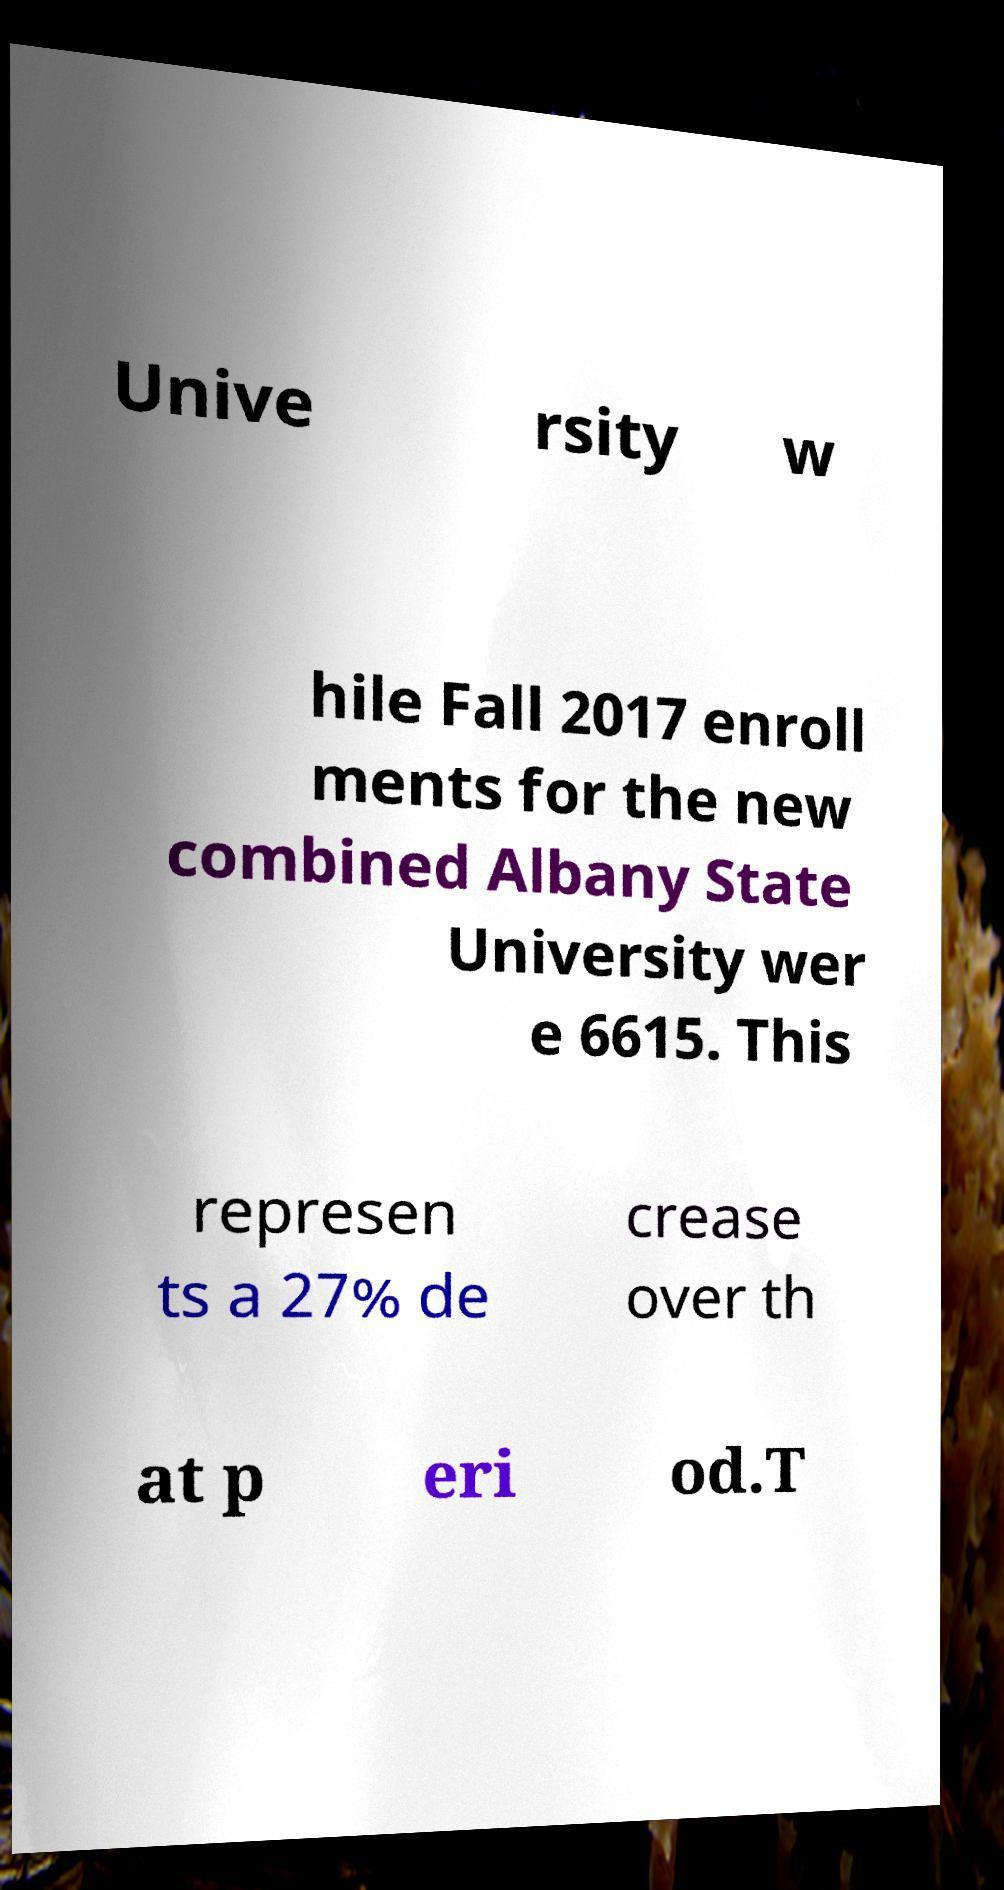Can you read and provide the text displayed in the image?This photo seems to have some interesting text. Can you extract and type it out for me? Unive rsity w hile Fall 2017 enroll ments for the new combined Albany State University wer e 6615. This represen ts a 27% de crease over th at p eri od.T 